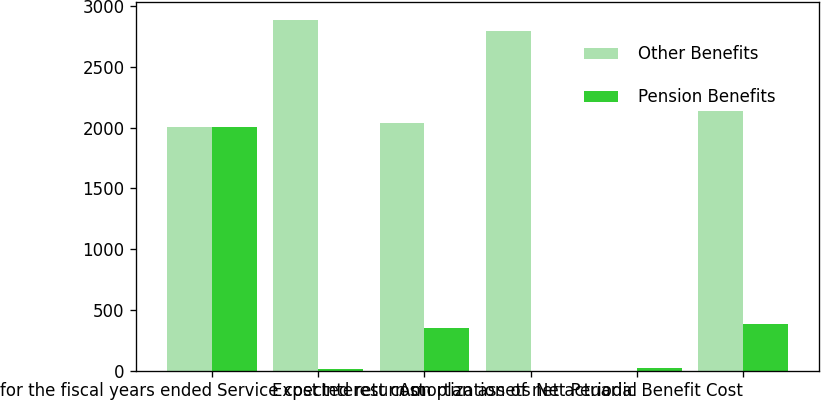<chart> <loc_0><loc_0><loc_500><loc_500><stacked_bar_chart><ecel><fcel>for the fiscal years ended<fcel>Service cost<fcel>Interest cost<fcel>Expected return on plan assets<fcel>Amortization of net actuarial<fcel>Net Periodic Benefit Cost<nl><fcel>Other Benefits<fcel>2010<fcel>2891<fcel>2041<fcel>2793<fcel>0<fcel>2139<nl><fcel>Pension Benefits<fcel>2010<fcel>11<fcel>353<fcel>0<fcel>23<fcel>387<nl></chart> 